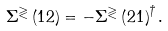Convert formula to latex. <formula><loc_0><loc_0><loc_500><loc_500>\Sigma ^ { \gtrless } \left ( 1 2 \right ) = - \Sigma ^ { \gtrless } \left ( 2 1 \right ) ^ { \dagger } .</formula> 